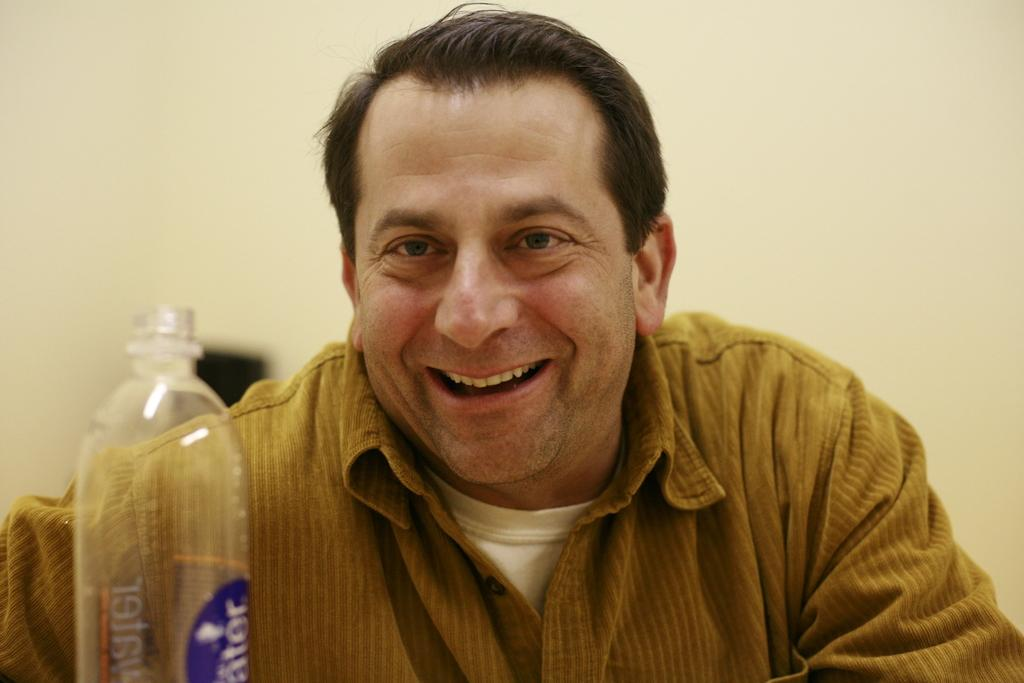What is the facial expression of the person in the image? The person is smiling. What object is in front of the person? There is a bottle in front of the person. How many angles can be seen in the person's thought process in the image? There is no indication of the person's thought process or angles in the image. 